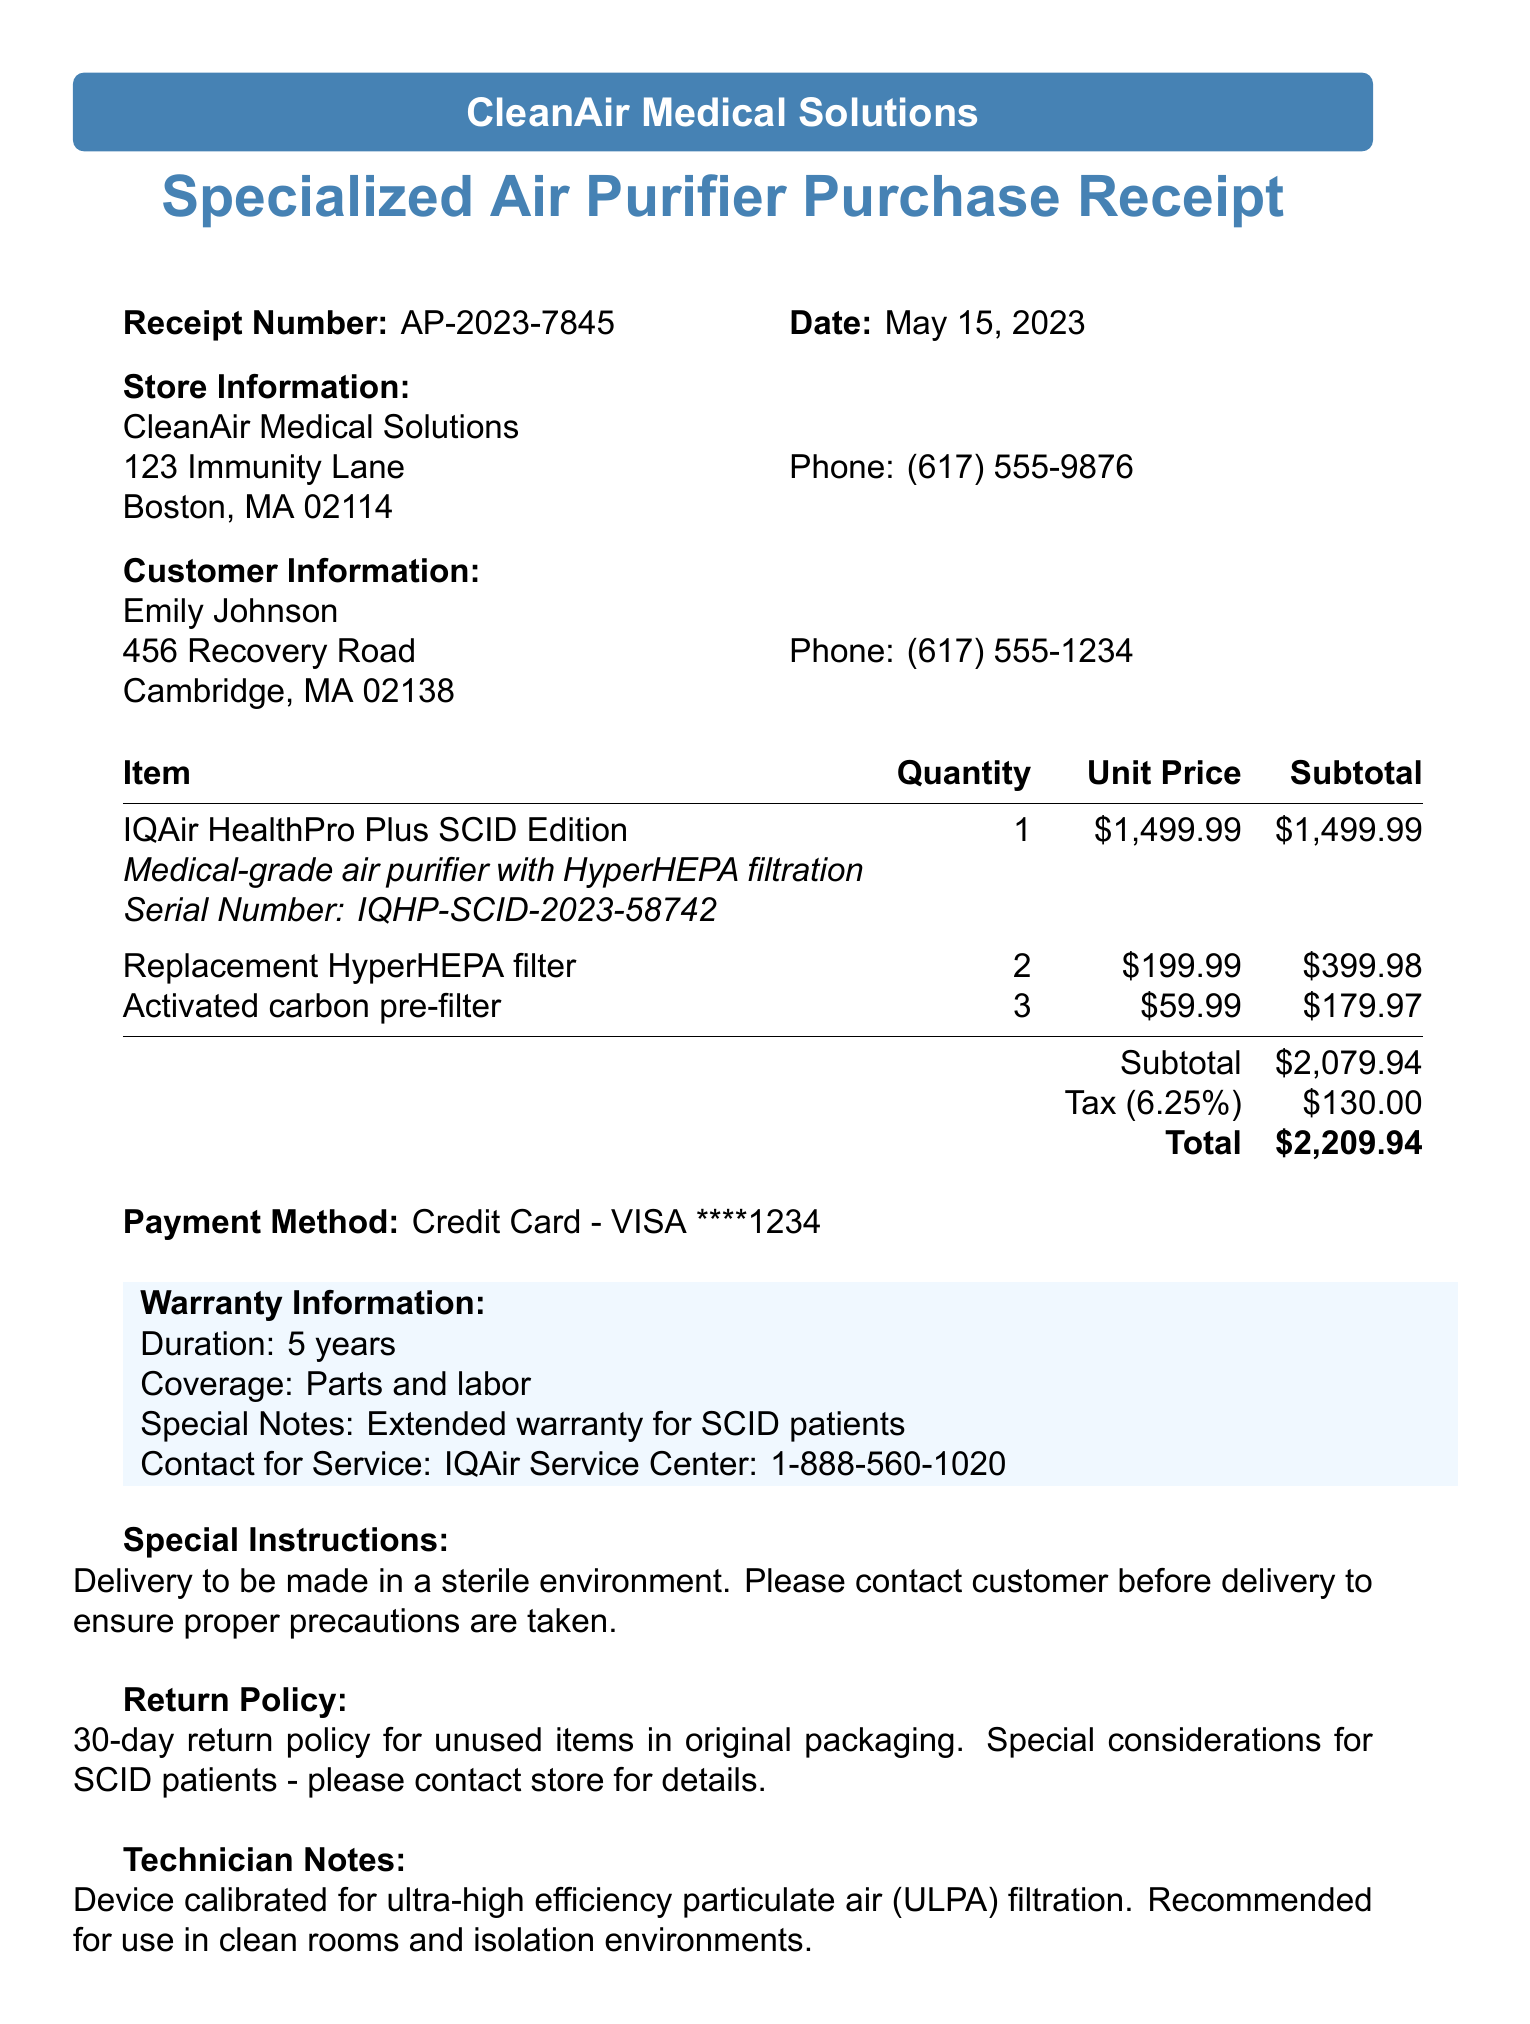What is the receipt number? The receipt number is specifically mentioned at the top of the document.
Answer: AP-2023-7845 What is the date of purchase? The date of purchase is listed alongside the receipt number.
Answer: May 15, 2023 What is the total amount paid? The total amount is calculated and displayed at the bottom of the transaction items.
Answer: $1593.74 What is the warranty duration? Warranty information is provided, detailing the duration.
Answer: 5 years What product was purchased? The product name is prominently featured in the item list of the receipt.
Answer: IQAir HealthPro Plus SCID Edition How many replacement filters were bought? The quantity of the specific additional item is listed in the receipt.
Answer: 2 What special notes are provided regarding the warranty? The warranty section includes specific notes about its coverage.
Answer: Extended warranty for SCID patients What is the store phone number? The contact number for the store is provided under the store information.
Answer: (617) 555-9876 What is the return policy for unused items? The return policy details are stated clearly in the document.
Answer: 30-day return policy for unused items in original packaging 